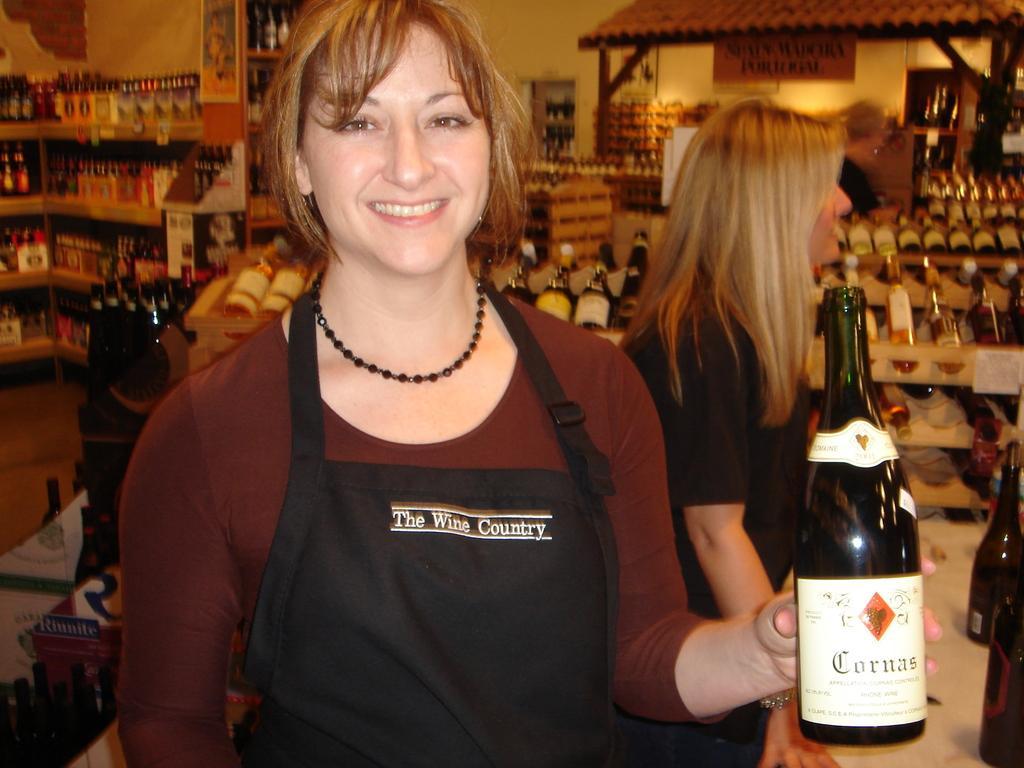How would you summarize this image in a sentence or two? This is a picture of a woman in brown t shirt holding a wine bottle. Background of this woman there are shelves with full of bottles and wall. 